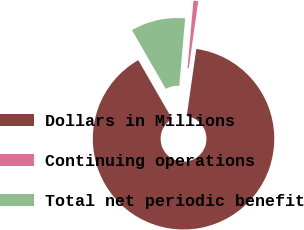Convert chart to OTSL. <chart><loc_0><loc_0><loc_500><loc_500><pie_chart><fcel>Dollars in Millions<fcel>Continuing operations<fcel>Total net periodic benefit<nl><fcel>89.45%<fcel>0.85%<fcel>9.71%<nl></chart> 